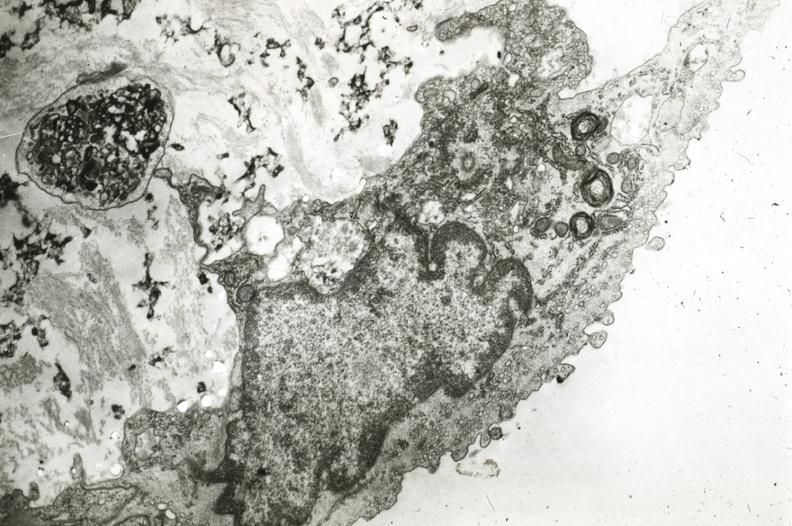where is this?
Answer the question using a single word or phrase. Vasculature 